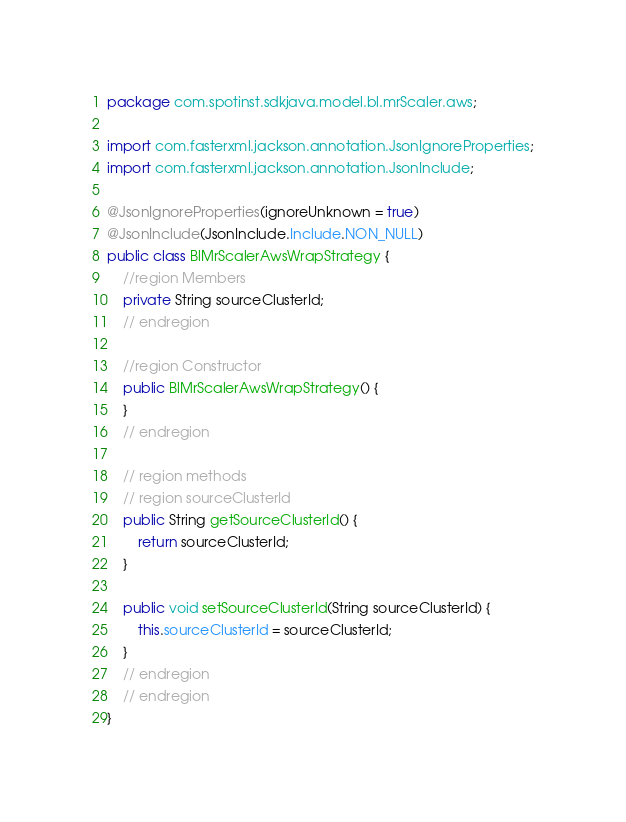Convert code to text. <code><loc_0><loc_0><loc_500><loc_500><_Java_>package com.spotinst.sdkjava.model.bl.mrScaler.aws;

import com.fasterxml.jackson.annotation.JsonIgnoreProperties;
import com.fasterxml.jackson.annotation.JsonInclude;

@JsonIgnoreProperties(ignoreUnknown = true)
@JsonInclude(JsonInclude.Include.NON_NULL)
public class BlMrScalerAwsWrapStrategy {
    //region Members
    private String sourceClusterId;
    // endregion

    //region Constructor
    public BlMrScalerAwsWrapStrategy() {
    }
    // endregion

    // region methods
    // region sourceClusterId
    public String getSourceClusterId() {
        return sourceClusterId;
    }

    public void setSourceClusterId(String sourceClusterId) {
        this.sourceClusterId = sourceClusterId;
    }
    // endregion
    // endregion
}
</code> 